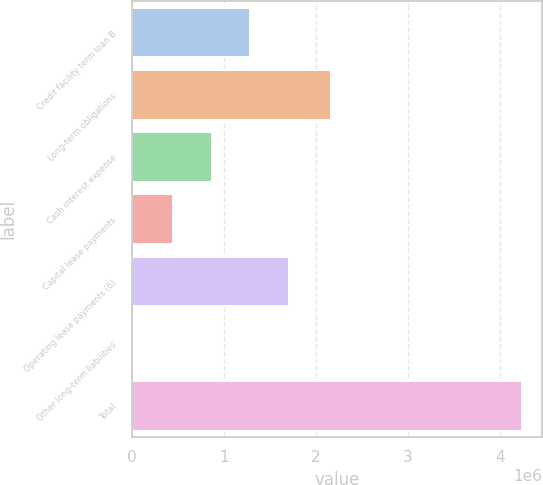Convert chart. <chart><loc_0><loc_0><loc_500><loc_500><bar_chart><fcel>Credit facility term loan B<fcel>Long-term obligations<fcel>Cash interest expense<fcel>Capital lease payments<fcel>Operating lease payments (6)<fcel>Other long-term liabilities<fcel>Total<nl><fcel>1.28992e+06<fcel>2.163e+06<fcel>868249<fcel>446579<fcel>1.71159e+06<fcel>24909<fcel>4.24161e+06<nl></chart> 